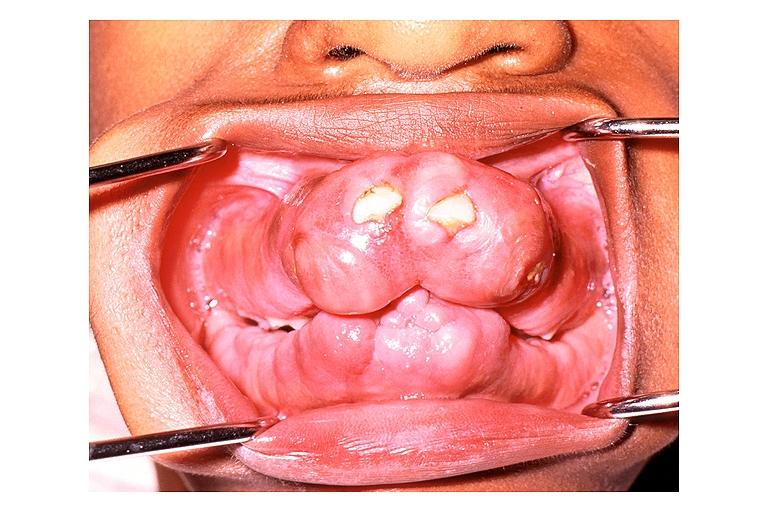does this image show gingival fibromatosis?
Answer the question using a single word or phrase. Yes 